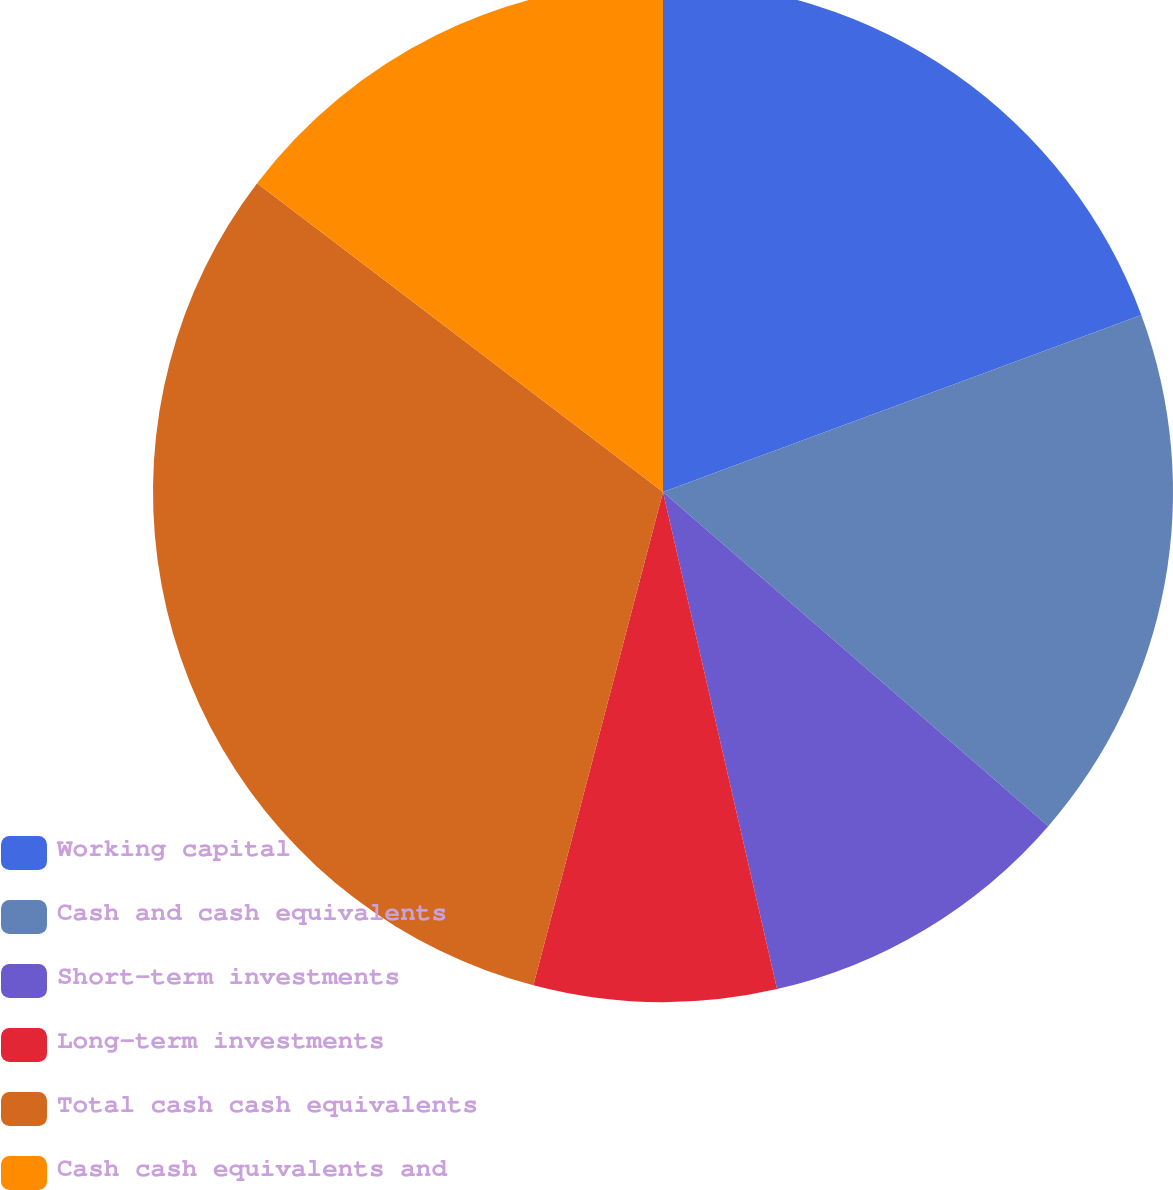Convert chart. <chart><loc_0><loc_0><loc_500><loc_500><pie_chart><fcel>Working capital<fcel>Cash and cash equivalents<fcel>Short-term investments<fcel>Long-term investments<fcel>Total cash cash equivalents<fcel>Cash cash equivalents and<nl><fcel>19.36%<fcel>17.01%<fcel>10.04%<fcel>7.68%<fcel>31.26%<fcel>14.65%<nl></chart> 